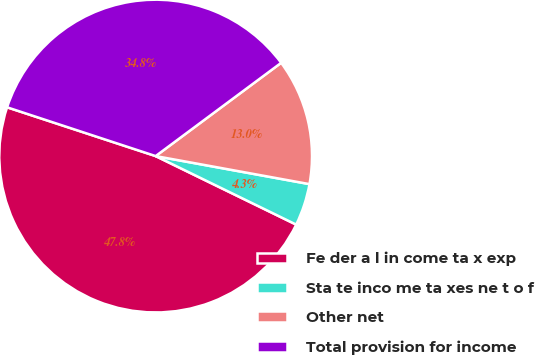Convert chart to OTSL. <chart><loc_0><loc_0><loc_500><loc_500><pie_chart><fcel>Fe der a l in come ta x exp<fcel>Sta te inco me ta xes ne t o f<fcel>Other net<fcel>Total provision for income<nl><fcel>47.83%<fcel>4.35%<fcel>13.04%<fcel>34.78%<nl></chart> 